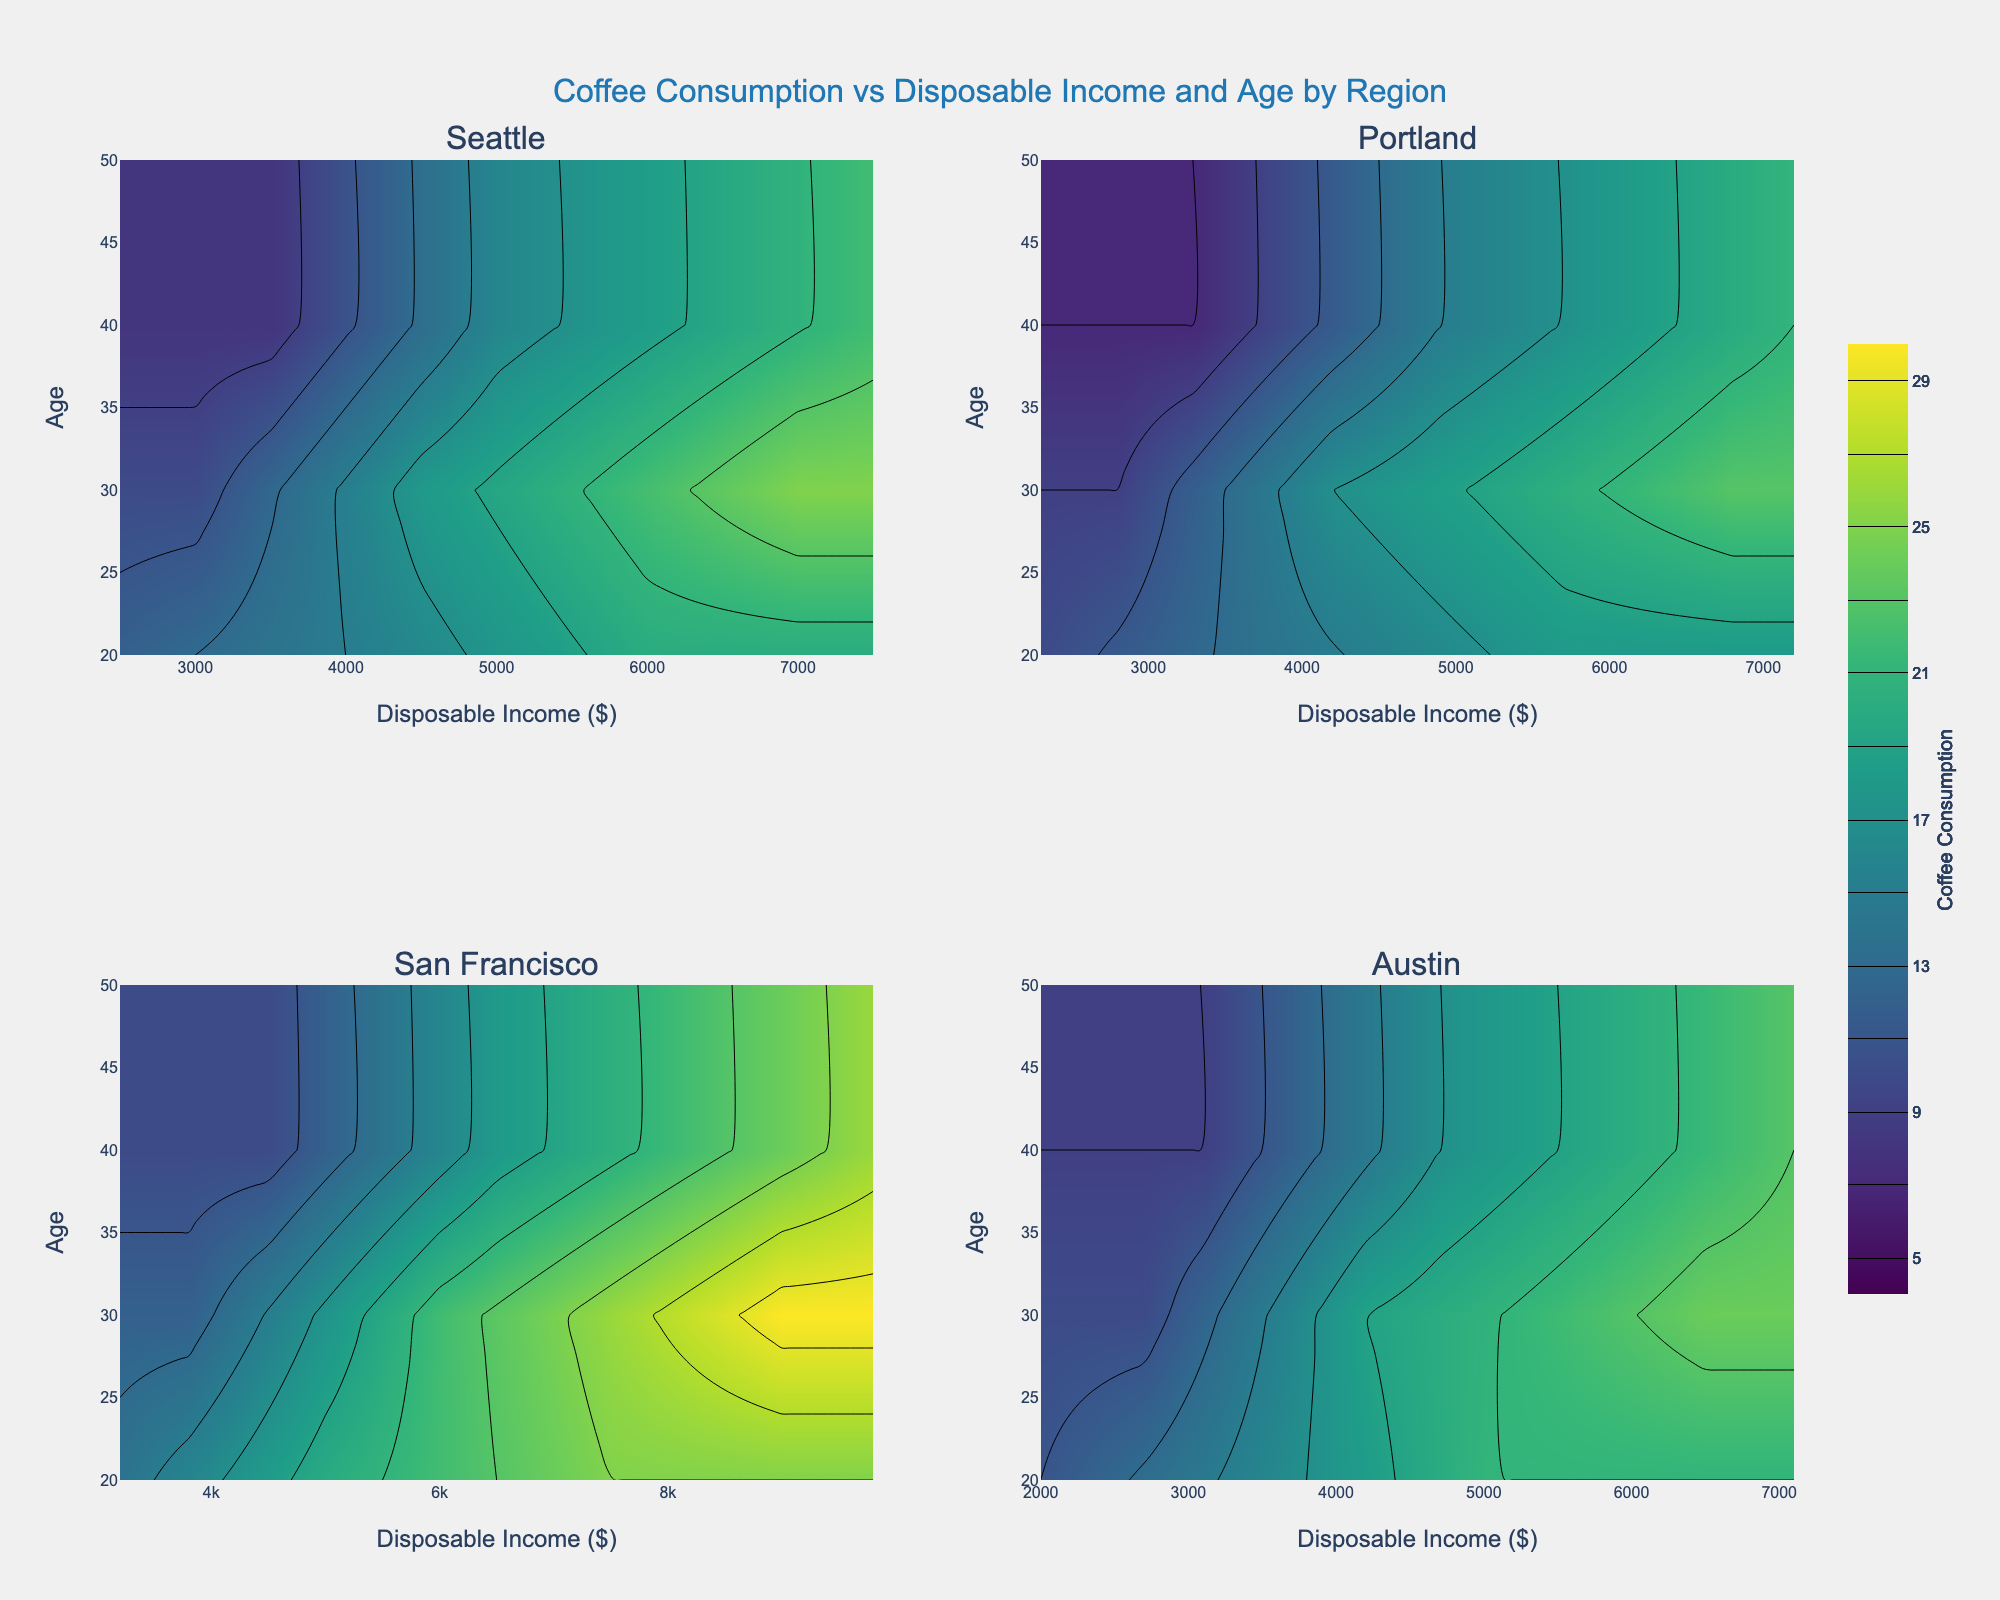What's the title of the figure? The figure's title is usually placed at the top center of the chart. In this case, it states the main subject of the figure, which is the relationship between coffee consumption, disposable income, and age across different regions.
Answer: Coffee Consumption vs Disposable Income and Age by Region What disposable income range does the contour cover in the Seattle subplot? Looking at the x-axis of the Seattle subplot, we notice the range for disposable income is from the minimum to the maximum value present in the data for Seattle region, usually marked by the axis ticks.
Answer: $2500 to $7500 Which region shows the highest average monthly coffee consumption for the '30-40' age group? We compare the maximum value on the z-axis for the contour in the '30-40' section across all regions. For '30-40', the contours tend to reach the highest coffee consumption in San Francisco.
Answer: San Francisco Which age group has the least coffee consumption for the 'Low' income bracket in Portland? By observing the contours in the Portland subplot and checking where the lower Z values (<10) appear for the 'Low' income bracket, we can infer the insights. For the 'Low' income bracket, the '40-50' age group tends to fall at the lower end of coffee consumption.
Answer: 40-50 How does the coffee consumption for the 'Medium' income bracket differ between Seattle and Austin for the '30-40' age group? We compare the Z values (color intensities) at the intersection of the 'Medium' income bracket and '30-40' age group in both Seattle and Austin subplots. Seattle shows higher values (brighter colors) than Austin for this demographic.
Answer: Higher in Seattle What trend can be observed for the age group '40-50' as disposable income increases in San Francisco? We look at the color variation along the y-axis corresponding to '40-50' as the disposable income (x-axis) increases in the San Francisco subplot. The trend shows an increase in coffee consumption, indicated by color intensities becoming stronger.
Answer: Coffee consumption increases Which region shows the widest range of coffee consumption values across all age groups and income brackets? By observing the contour ranges in all subplots, the San Francisco subplot displays the widest range from the lowest to the highest Z values, showing the most varying coffee consumption rates.
Answer: San Francisco How does the plot indicate changes in coffee consumption as people age in Austin for the highest income bracket? Checking the Austin subplot, we observe the highest income bracket and see how the Z values (color intensities) change across age groups on the y-axis. An increasing trend of coffee consumption is indicated in Austin as people age.
Answer: It increases as people age 